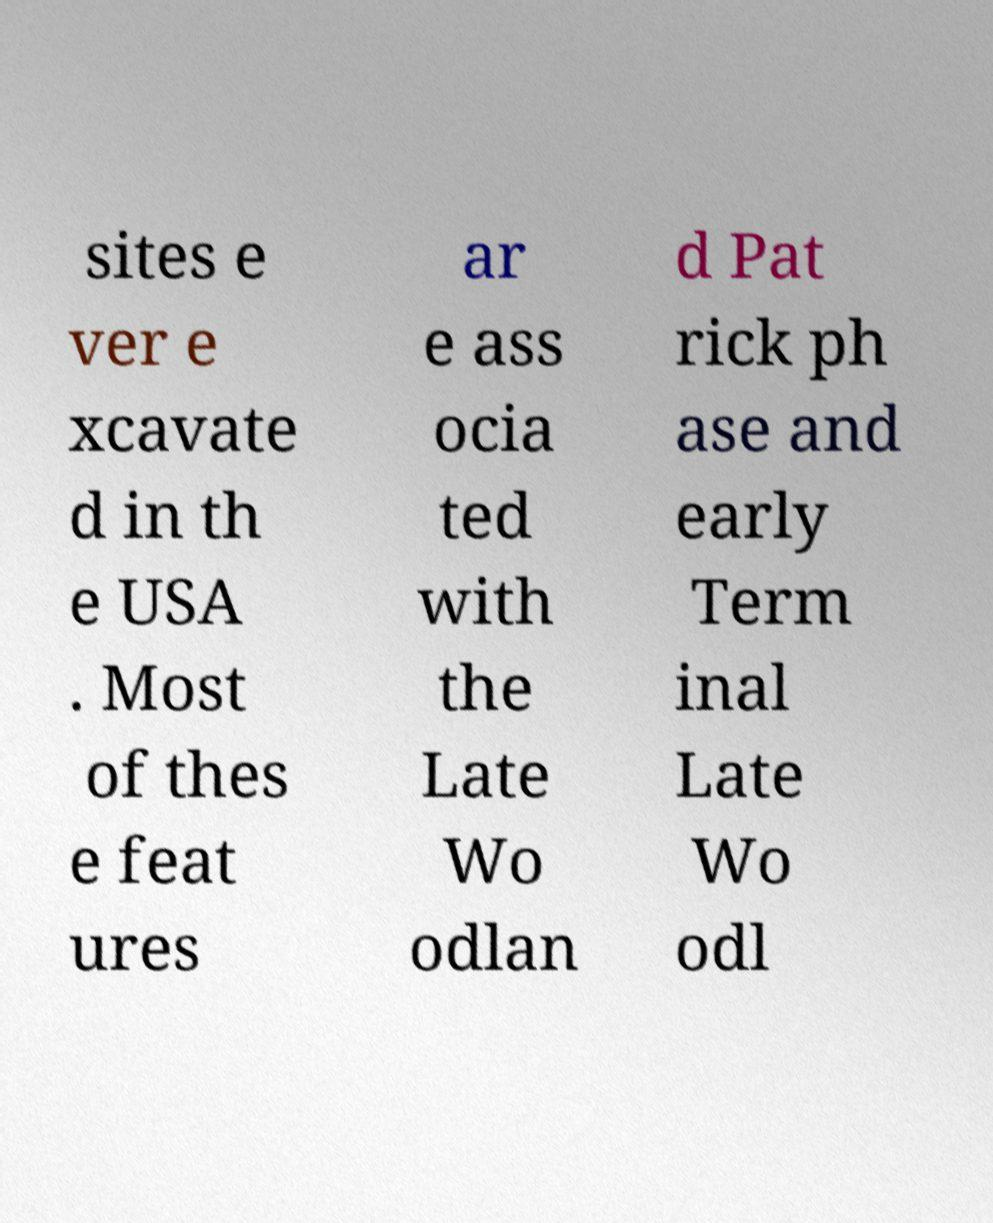Could you assist in decoding the text presented in this image and type it out clearly? sites e ver e xcavate d in th e USA . Most of thes e feat ures ar e ass ocia ted with the Late Wo odlan d Pat rick ph ase and early Term inal Late Wo odl 